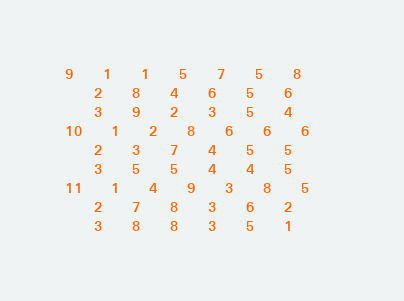<code> <loc_0><loc_0><loc_500><loc_500><_ObjectiveC_>9	1	1	5	7	5	8	
	2	8	4	6	5	6	
	3	9	2	3	5	4	
10	1	2	8	6	6	6	
	2	3	7	4	5	5	
	3	5	5	4	4	5	
11	1	4	9	3	8	5	
	2	7	8	3	6	2	
	3	8	8	3	5	1	</code> 